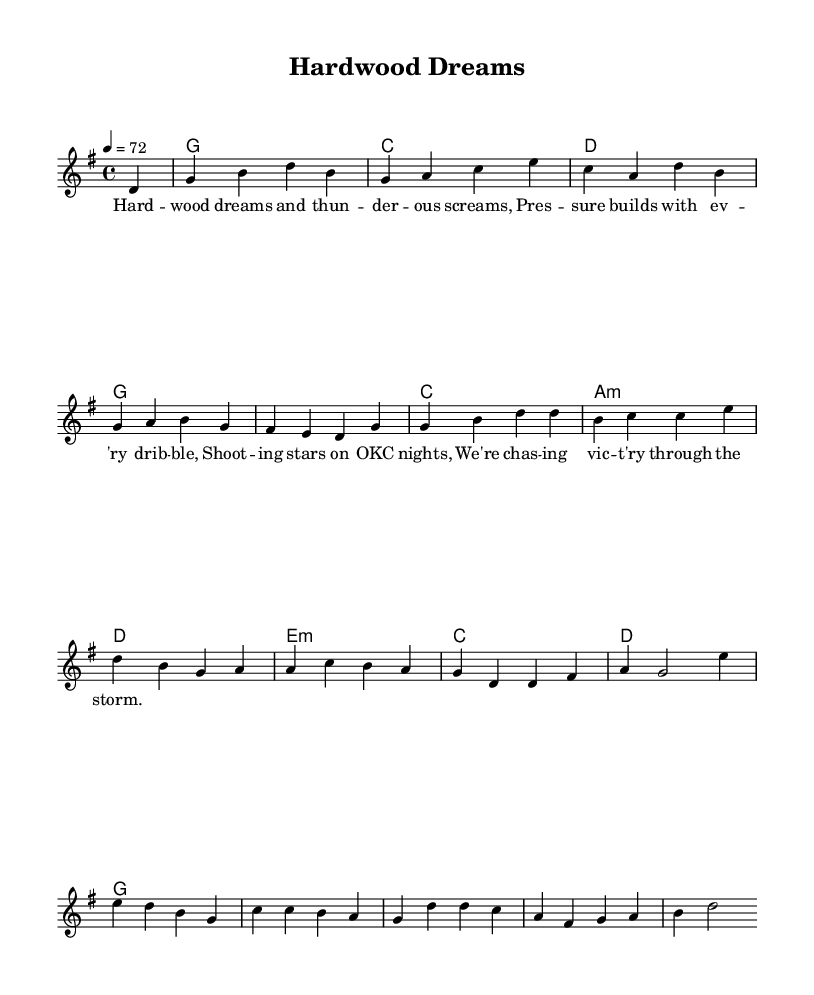What is the key signature of this music? The key signature can be identified by looking at the number of sharps or flats; this piece has one sharp, which means it is in G major.
Answer: G major What is the time signature of this music? The time signature is indicated at the beginning of the piece, shown as 4/4, which means four beats per measure.
Answer: 4/4 What is the tempo marking of the piece? The tempo marking is found at the start of the sheet music, which states that the tempo is quarter note equals seventy-two beats per minute.
Answer: 72 How many measures are in the melody section? By counting the number of vertical lines or bar lines, we can determine that there are ten measures in the melody section.
Answer: 10 What is the first chord in the piece? The first chord is shown immediately after the initial chord symbols in the harmony, which indicates the chord is G major.
Answer: G What lyrical theme is explored in this piece? The lyrics reflect on the pressures of sports and the pursuit of victory, drawing on imagery relevant to basketball and competition.
Answer: Pressure 